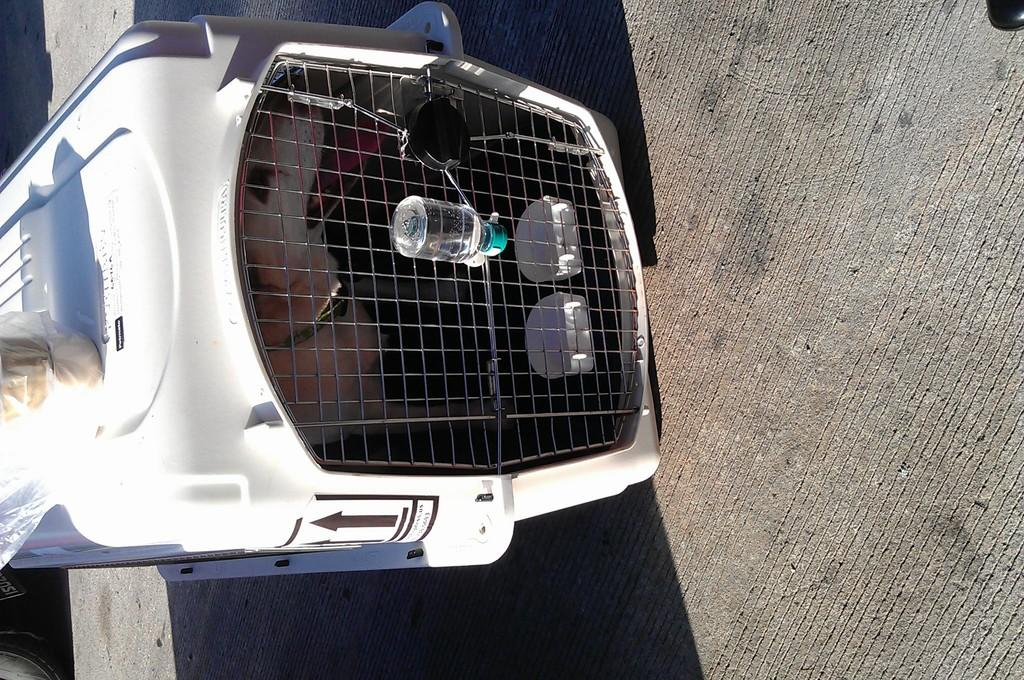What type of animal is in the image? There is a dog in the image. Where is the dog located? The dog is in a cage. What kind of cage is it? The cage appears to be a dog cage. What else can be seen in the image? There is a water bottle in the image. What type of oil can be seen dripping from the dog's fur in the image? There is no oil present in the image, and the dog's fur does not appear to be dripping with any substance. 